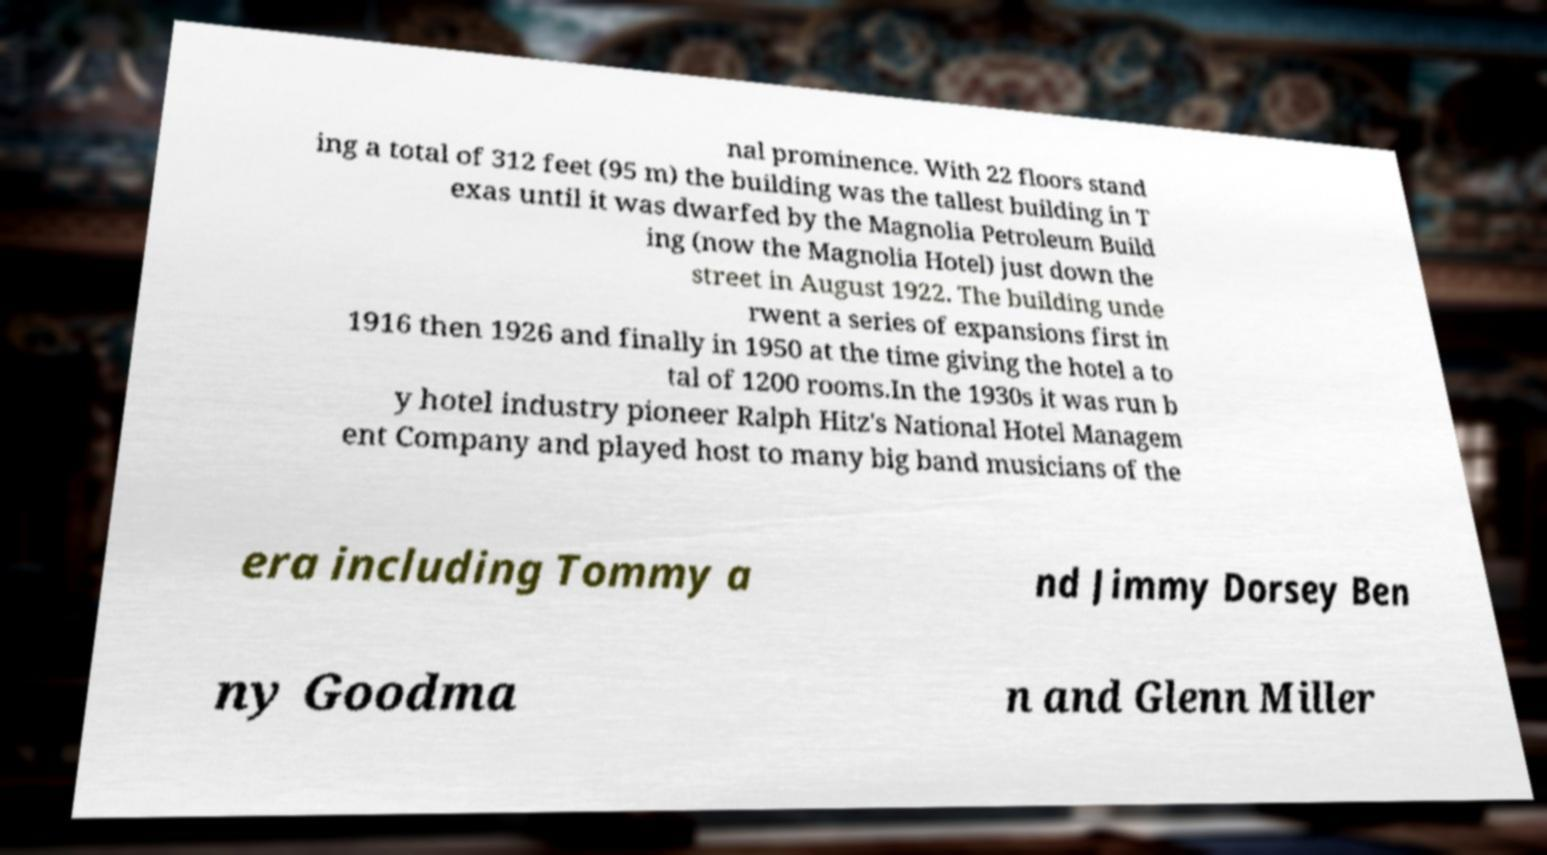Please identify and transcribe the text found in this image. nal prominence. With 22 floors stand ing a total of 312 feet (95 m) the building was the tallest building in T exas until it was dwarfed by the Magnolia Petroleum Build ing (now the Magnolia Hotel) just down the street in August 1922. The building unde rwent a series of expansions first in 1916 then 1926 and finally in 1950 at the time giving the hotel a to tal of 1200 rooms.In the 1930s it was run b y hotel industry pioneer Ralph Hitz's National Hotel Managem ent Company and played host to many big band musicians of the era including Tommy a nd Jimmy Dorsey Ben ny Goodma n and Glenn Miller 